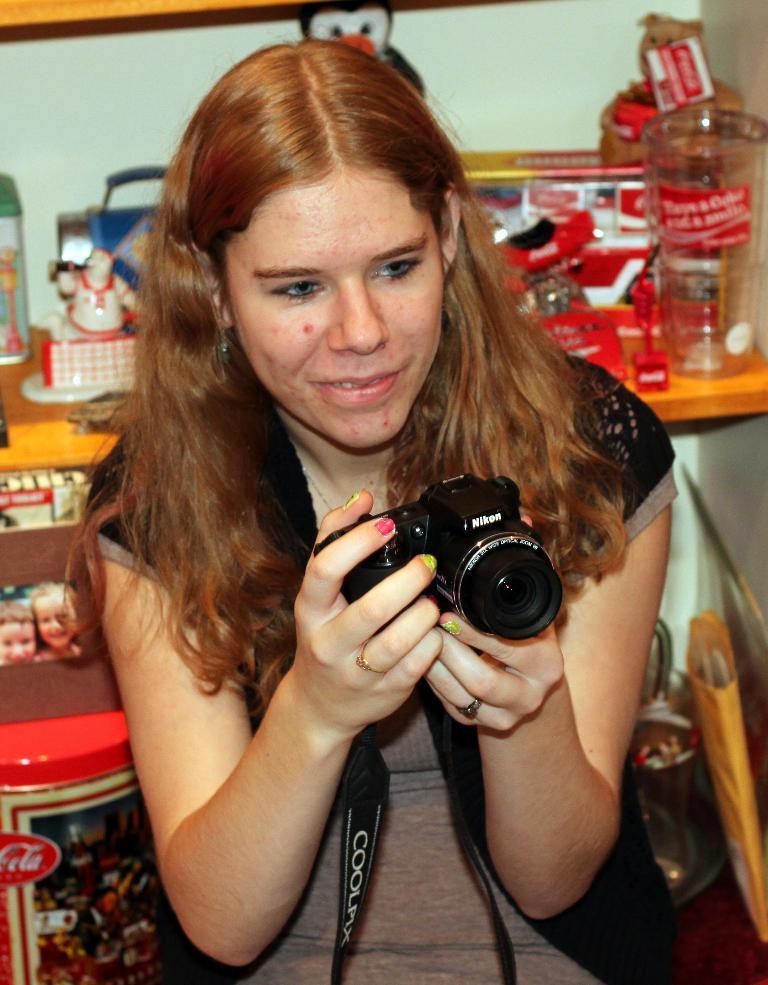Could you give a brief overview of what you see in this image? In this image I can see a woman wearing black and brown dress is holding a black colored camera in her hand. In the background I can see a brown colored desk and on the desk I can see few jars, few toys and few other objects. I can see the white colored wall. 